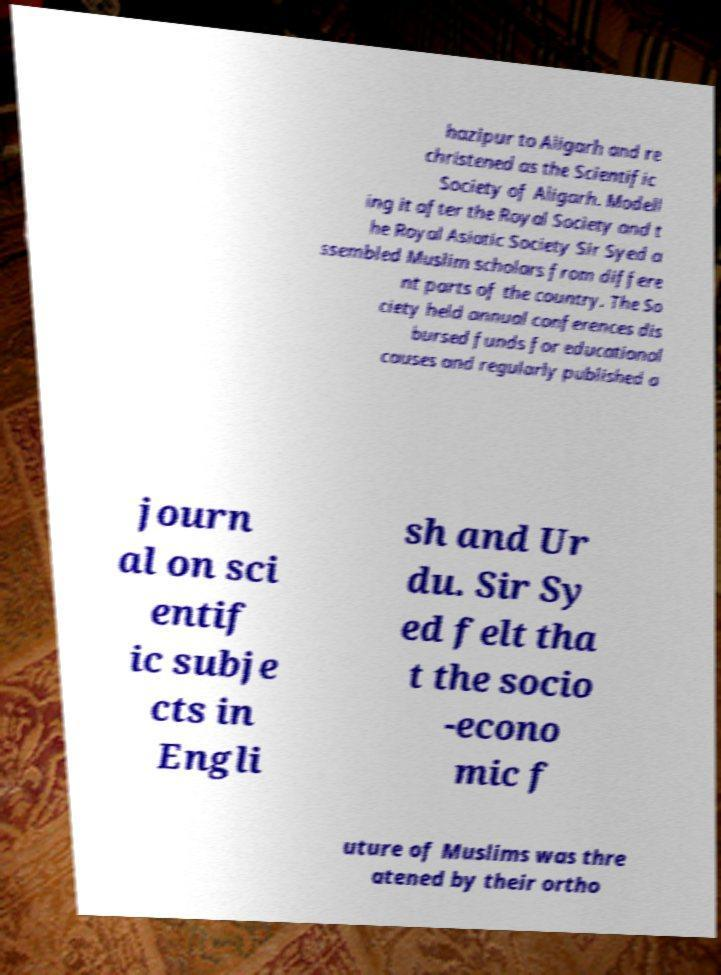Could you assist in decoding the text presented in this image and type it out clearly? hazipur to Aligarh and re christened as the Scientific Society of Aligarh. Modell ing it after the Royal Society and t he Royal Asiatic Society Sir Syed a ssembled Muslim scholars from differe nt parts of the country. The So ciety held annual conferences dis bursed funds for educational causes and regularly published a journ al on sci entif ic subje cts in Engli sh and Ur du. Sir Sy ed felt tha t the socio -econo mic f uture of Muslims was thre atened by their ortho 